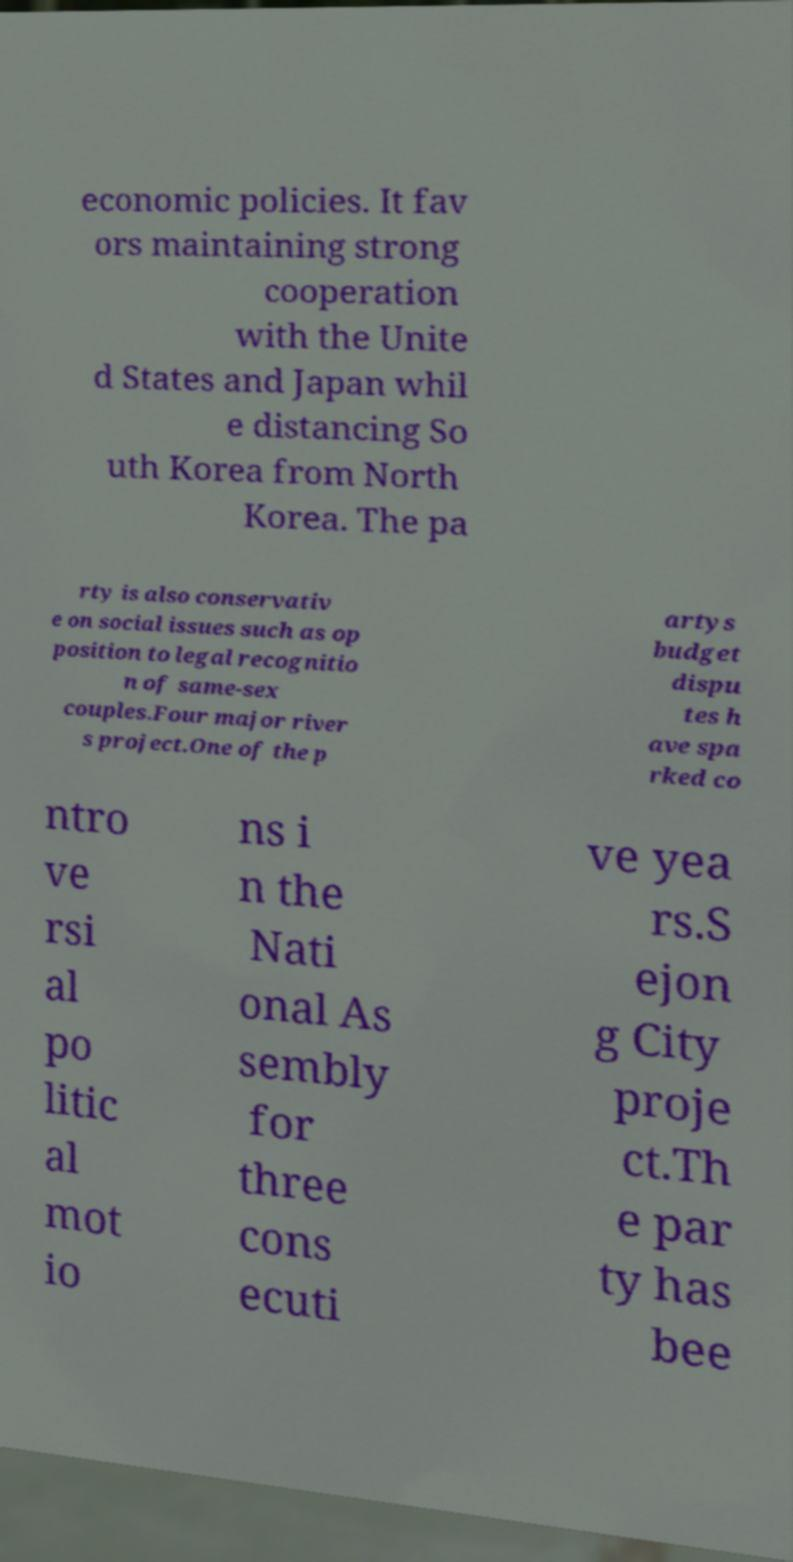Please read and relay the text visible in this image. What does it say? economic policies. It fav ors maintaining strong cooperation with the Unite d States and Japan whil e distancing So uth Korea from North Korea. The pa rty is also conservativ e on social issues such as op position to legal recognitio n of same-sex couples.Four major river s project.One of the p artys budget dispu tes h ave spa rked co ntro ve rsi al po litic al mot io ns i n the Nati onal As sembly for three cons ecuti ve yea rs.S ejon g City proje ct.Th e par ty has bee 